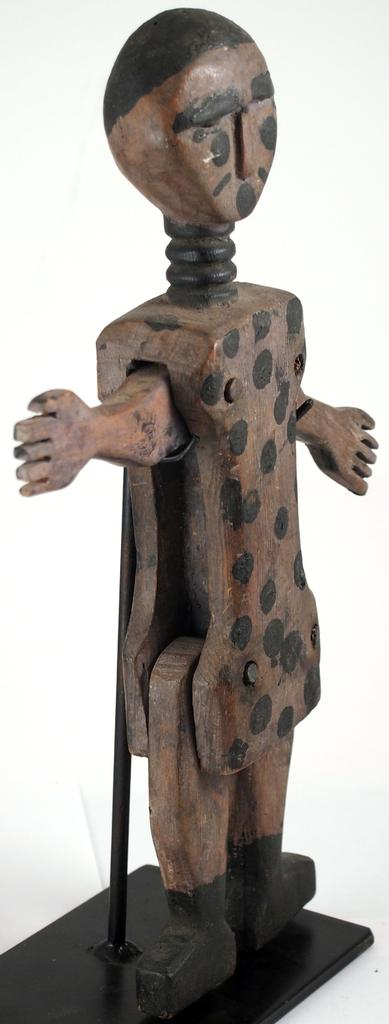What is the main subject in the image? There is a wooden statue in the image. How is the wooden statue supported? The wooden statue is attached to a stand. What color is the background of the image? The background of the image is white. How many men are participating in the competition shown in the image? There is no competition or men present in the image; it features a wooden statue attached to a stand with a white background. 